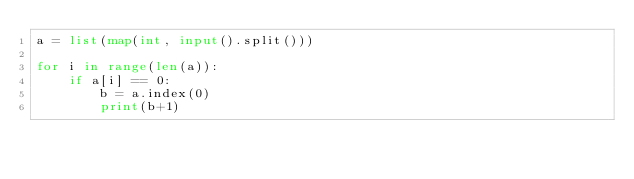<code> <loc_0><loc_0><loc_500><loc_500><_Python_>a = list(map(int, input().split()))

for i in range(len(a)):
    if a[i] == 0:
        b = a.index(0)
        print(b+1)
</code> 